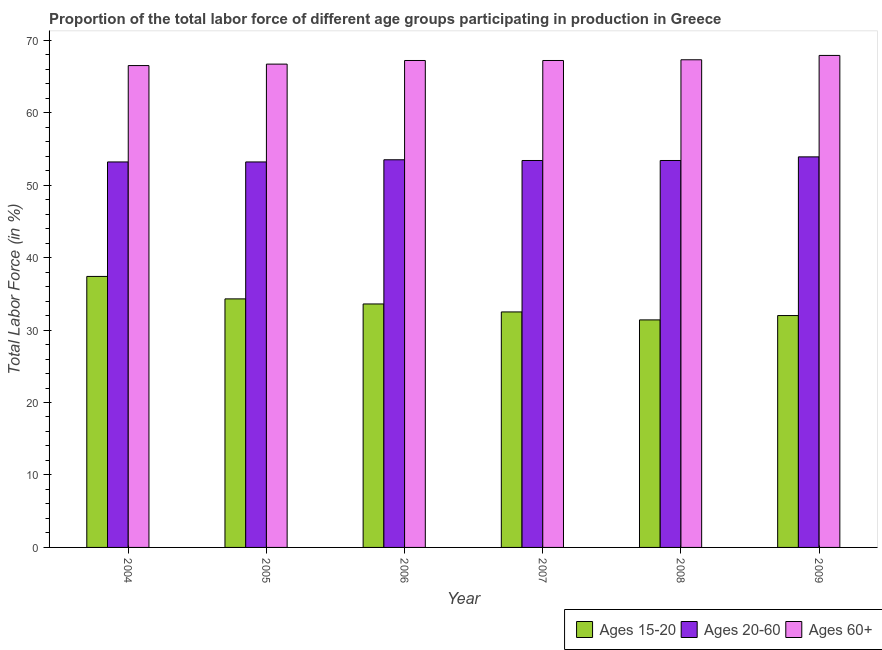How many groups of bars are there?
Offer a very short reply. 6. Are the number of bars on each tick of the X-axis equal?
Your answer should be compact. Yes. How many bars are there on the 2nd tick from the right?
Provide a short and direct response. 3. What is the label of the 1st group of bars from the left?
Your answer should be very brief. 2004. What is the percentage of labor force above age 60 in 2009?
Give a very brief answer. 67.9. Across all years, what is the maximum percentage of labor force within the age group 15-20?
Provide a short and direct response. 37.4. Across all years, what is the minimum percentage of labor force within the age group 15-20?
Make the answer very short. 31.4. In which year was the percentage of labor force within the age group 15-20 minimum?
Give a very brief answer. 2008. What is the total percentage of labor force within the age group 15-20 in the graph?
Provide a short and direct response. 201.2. What is the difference between the percentage of labor force above age 60 in 2007 and that in 2009?
Your answer should be very brief. -0.7. What is the difference between the percentage of labor force above age 60 in 2008 and the percentage of labor force within the age group 20-60 in 2009?
Provide a succinct answer. -0.6. What is the average percentage of labor force above age 60 per year?
Your response must be concise. 67.13. In the year 2007, what is the difference between the percentage of labor force within the age group 15-20 and percentage of labor force above age 60?
Make the answer very short. 0. In how many years, is the percentage of labor force within the age group 20-60 greater than 58 %?
Your answer should be compact. 0. What is the ratio of the percentage of labor force within the age group 15-20 in 2006 to that in 2007?
Offer a very short reply. 1.03. Is the percentage of labor force within the age group 20-60 in 2004 less than that in 2008?
Your answer should be very brief. Yes. Is the difference between the percentage of labor force within the age group 15-20 in 2004 and 2005 greater than the difference between the percentage of labor force within the age group 20-60 in 2004 and 2005?
Give a very brief answer. No. What is the difference between the highest and the second highest percentage of labor force within the age group 20-60?
Keep it short and to the point. 0.4. What is the difference between the highest and the lowest percentage of labor force within the age group 20-60?
Provide a succinct answer. 0.7. What does the 1st bar from the left in 2009 represents?
Give a very brief answer. Ages 15-20. What does the 2nd bar from the right in 2005 represents?
Keep it short and to the point. Ages 20-60. Is it the case that in every year, the sum of the percentage of labor force within the age group 15-20 and percentage of labor force within the age group 20-60 is greater than the percentage of labor force above age 60?
Offer a very short reply. Yes. Are all the bars in the graph horizontal?
Offer a very short reply. No. How many years are there in the graph?
Your answer should be very brief. 6. Does the graph contain grids?
Provide a short and direct response. No. How are the legend labels stacked?
Your answer should be compact. Horizontal. What is the title of the graph?
Offer a very short reply. Proportion of the total labor force of different age groups participating in production in Greece. What is the Total Labor Force (in %) in Ages 15-20 in 2004?
Your response must be concise. 37.4. What is the Total Labor Force (in %) of Ages 20-60 in 2004?
Offer a very short reply. 53.2. What is the Total Labor Force (in %) in Ages 60+ in 2004?
Keep it short and to the point. 66.5. What is the Total Labor Force (in %) of Ages 15-20 in 2005?
Ensure brevity in your answer.  34.3. What is the Total Labor Force (in %) in Ages 20-60 in 2005?
Ensure brevity in your answer.  53.2. What is the Total Labor Force (in %) of Ages 60+ in 2005?
Provide a short and direct response. 66.7. What is the Total Labor Force (in %) in Ages 15-20 in 2006?
Make the answer very short. 33.6. What is the Total Labor Force (in %) of Ages 20-60 in 2006?
Provide a short and direct response. 53.5. What is the Total Labor Force (in %) in Ages 60+ in 2006?
Offer a very short reply. 67.2. What is the Total Labor Force (in %) in Ages 15-20 in 2007?
Keep it short and to the point. 32.5. What is the Total Labor Force (in %) in Ages 20-60 in 2007?
Your answer should be very brief. 53.4. What is the Total Labor Force (in %) of Ages 60+ in 2007?
Ensure brevity in your answer.  67.2. What is the Total Labor Force (in %) of Ages 15-20 in 2008?
Provide a short and direct response. 31.4. What is the Total Labor Force (in %) of Ages 20-60 in 2008?
Keep it short and to the point. 53.4. What is the Total Labor Force (in %) of Ages 60+ in 2008?
Provide a succinct answer. 67.3. What is the Total Labor Force (in %) of Ages 20-60 in 2009?
Give a very brief answer. 53.9. What is the Total Labor Force (in %) of Ages 60+ in 2009?
Offer a terse response. 67.9. Across all years, what is the maximum Total Labor Force (in %) of Ages 15-20?
Provide a short and direct response. 37.4. Across all years, what is the maximum Total Labor Force (in %) of Ages 20-60?
Offer a very short reply. 53.9. Across all years, what is the maximum Total Labor Force (in %) in Ages 60+?
Keep it short and to the point. 67.9. Across all years, what is the minimum Total Labor Force (in %) in Ages 15-20?
Your answer should be very brief. 31.4. Across all years, what is the minimum Total Labor Force (in %) in Ages 20-60?
Offer a very short reply. 53.2. Across all years, what is the minimum Total Labor Force (in %) of Ages 60+?
Provide a succinct answer. 66.5. What is the total Total Labor Force (in %) in Ages 15-20 in the graph?
Your answer should be compact. 201.2. What is the total Total Labor Force (in %) in Ages 20-60 in the graph?
Your answer should be very brief. 320.6. What is the total Total Labor Force (in %) of Ages 60+ in the graph?
Keep it short and to the point. 402.8. What is the difference between the Total Labor Force (in %) in Ages 15-20 in 2004 and that in 2005?
Your answer should be very brief. 3.1. What is the difference between the Total Labor Force (in %) of Ages 60+ in 2004 and that in 2005?
Ensure brevity in your answer.  -0.2. What is the difference between the Total Labor Force (in %) in Ages 15-20 in 2004 and that in 2006?
Keep it short and to the point. 3.8. What is the difference between the Total Labor Force (in %) of Ages 20-60 in 2004 and that in 2006?
Offer a terse response. -0.3. What is the difference between the Total Labor Force (in %) of Ages 60+ in 2004 and that in 2008?
Make the answer very short. -0.8. What is the difference between the Total Labor Force (in %) in Ages 60+ in 2004 and that in 2009?
Keep it short and to the point. -1.4. What is the difference between the Total Labor Force (in %) in Ages 15-20 in 2005 and that in 2006?
Your response must be concise. 0.7. What is the difference between the Total Labor Force (in %) in Ages 20-60 in 2005 and that in 2006?
Provide a short and direct response. -0.3. What is the difference between the Total Labor Force (in %) of Ages 60+ in 2005 and that in 2006?
Your answer should be compact. -0.5. What is the difference between the Total Labor Force (in %) of Ages 20-60 in 2005 and that in 2007?
Your response must be concise. -0.2. What is the difference between the Total Labor Force (in %) of Ages 60+ in 2005 and that in 2007?
Keep it short and to the point. -0.5. What is the difference between the Total Labor Force (in %) in Ages 15-20 in 2005 and that in 2008?
Make the answer very short. 2.9. What is the difference between the Total Labor Force (in %) of Ages 60+ in 2005 and that in 2008?
Ensure brevity in your answer.  -0.6. What is the difference between the Total Labor Force (in %) in Ages 15-20 in 2005 and that in 2009?
Make the answer very short. 2.3. What is the difference between the Total Labor Force (in %) in Ages 20-60 in 2005 and that in 2009?
Give a very brief answer. -0.7. What is the difference between the Total Labor Force (in %) of Ages 15-20 in 2006 and that in 2007?
Offer a terse response. 1.1. What is the difference between the Total Labor Force (in %) in Ages 60+ in 2006 and that in 2007?
Provide a short and direct response. 0. What is the difference between the Total Labor Force (in %) in Ages 15-20 in 2006 and that in 2008?
Your answer should be very brief. 2.2. What is the difference between the Total Labor Force (in %) of Ages 60+ in 2006 and that in 2008?
Offer a very short reply. -0.1. What is the difference between the Total Labor Force (in %) of Ages 20-60 in 2006 and that in 2009?
Keep it short and to the point. -0.4. What is the difference between the Total Labor Force (in %) of Ages 20-60 in 2007 and that in 2008?
Provide a short and direct response. 0. What is the difference between the Total Labor Force (in %) in Ages 15-20 in 2008 and that in 2009?
Offer a very short reply. -0.6. What is the difference between the Total Labor Force (in %) in Ages 20-60 in 2008 and that in 2009?
Provide a short and direct response. -0.5. What is the difference between the Total Labor Force (in %) of Ages 60+ in 2008 and that in 2009?
Provide a succinct answer. -0.6. What is the difference between the Total Labor Force (in %) of Ages 15-20 in 2004 and the Total Labor Force (in %) of Ages 20-60 in 2005?
Offer a terse response. -15.8. What is the difference between the Total Labor Force (in %) in Ages 15-20 in 2004 and the Total Labor Force (in %) in Ages 60+ in 2005?
Your response must be concise. -29.3. What is the difference between the Total Labor Force (in %) of Ages 15-20 in 2004 and the Total Labor Force (in %) of Ages 20-60 in 2006?
Provide a short and direct response. -16.1. What is the difference between the Total Labor Force (in %) in Ages 15-20 in 2004 and the Total Labor Force (in %) in Ages 60+ in 2006?
Give a very brief answer. -29.8. What is the difference between the Total Labor Force (in %) in Ages 20-60 in 2004 and the Total Labor Force (in %) in Ages 60+ in 2006?
Give a very brief answer. -14. What is the difference between the Total Labor Force (in %) in Ages 15-20 in 2004 and the Total Labor Force (in %) in Ages 60+ in 2007?
Your answer should be compact. -29.8. What is the difference between the Total Labor Force (in %) of Ages 20-60 in 2004 and the Total Labor Force (in %) of Ages 60+ in 2007?
Provide a succinct answer. -14. What is the difference between the Total Labor Force (in %) of Ages 15-20 in 2004 and the Total Labor Force (in %) of Ages 60+ in 2008?
Give a very brief answer. -29.9. What is the difference between the Total Labor Force (in %) in Ages 20-60 in 2004 and the Total Labor Force (in %) in Ages 60+ in 2008?
Your answer should be compact. -14.1. What is the difference between the Total Labor Force (in %) in Ages 15-20 in 2004 and the Total Labor Force (in %) in Ages 20-60 in 2009?
Your response must be concise. -16.5. What is the difference between the Total Labor Force (in %) of Ages 15-20 in 2004 and the Total Labor Force (in %) of Ages 60+ in 2009?
Offer a very short reply. -30.5. What is the difference between the Total Labor Force (in %) in Ages 20-60 in 2004 and the Total Labor Force (in %) in Ages 60+ in 2009?
Offer a terse response. -14.7. What is the difference between the Total Labor Force (in %) of Ages 15-20 in 2005 and the Total Labor Force (in %) of Ages 20-60 in 2006?
Your answer should be compact. -19.2. What is the difference between the Total Labor Force (in %) of Ages 15-20 in 2005 and the Total Labor Force (in %) of Ages 60+ in 2006?
Your answer should be very brief. -32.9. What is the difference between the Total Labor Force (in %) in Ages 15-20 in 2005 and the Total Labor Force (in %) in Ages 20-60 in 2007?
Provide a succinct answer. -19.1. What is the difference between the Total Labor Force (in %) in Ages 15-20 in 2005 and the Total Labor Force (in %) in Ages 60+ in 2007?
Your answer should be very brief. -32.9. What is the difference between the Total Labor Force (in %) in Ages 15-20 in 2005 and the Total Labor Force (in %) in Ages 20-60 in 2008?
Offer a very short reply. -19.1. What is the difference between the Total Labor Force (in %) in Ages 15-20 in 2005 and the Total Labor Force (in %) in Ages 60+ in 2008?
Keep it short and to the point. -33. What is the difference between the Total Labor Force (in %) of Ages 20-60 in 2005 and the Total Labor Force (in %) of Ages 60+ in 2008?
Your response must be concise. -14.1. What is the difference between the Total Labor Force (in %) of Ages 15-20 in 2005 and the Total Labor Force (in %) of Ages 20-60 in 2009?
Ensure brevity in your answer.  -19.6. What is the difference between the Total Labor Force (in %) of Ages 15-20 in 2005 and the Total Labor Force (in %) of Ages 60+ in 2009?
Your answer should be very brief. -33.6. What is the difference between the Total Labor Force (in %) of Ages 20-60 in 2005 and the Total Labor Force (in %) of Ages 60+ in 2009?
Ensure brevity in your answer.  -14.7. What is the difference between the Total Labor Force (in %) of Ages 15-20 in 2006 and the Total Labor Force (in %) of Ages 20-60 in 2007?
Make the answer very short. -19.8. What is the difference between the Total Labor Force (in %) in Ages 15-20 in 2006 and the Total Labor Force (in %) in Ages 60+ in 2007?
Make the answer very short. -33.6. What is the difference between the Total Labor Force (in %) of Ages 20-60 in 2006 and the Total Labor Force (in %) of Ages 60+ in 2007?
Give a very brief answer. -13.7. What is the difference between the Total Labor Force (in %) in Ages 15-20 in 2006 and the Total Labor Force (in %) in Ages 20-60 in 2008?
Provide a succinct answer. -19.8. What is the difference between the Total Labor Force (in %) in Ages 15-20 in 2006 and the Total Labor Force (in %) in Ages 60+ in 2008?
Provide a succinct answer. -33.7. What is the difference between the Total Labor Force (in %) in Ages 15-20 in 2006 and the Total Labor Force (in %) in Ages 20-60 in 2009?
Your response must be concise. -20.3. What is the difference between the Total Labor Force (in %) in Ages 15-20 in 2006 and the Total Labor Force (in %) in Ages 60+ in 2009?
Offer a terse response. -34.3. What is the difference between the Total Labor Force (in %) of Ages 20-60 in 2006 and the Total Labor Force (in %) of Ages 60+ in 2009?
Give a very brief answer. -14.4. What is the difference between the Total Labor Force (in %) of Ages 15-20 in 2007 and the Total Labor Force (in %) of Ages 20-60 in 2008?
Provide a short and direct response. -20.9. What is the difference between the Total Labor Force (in %) of Ages 15-20 in 2007 and the Total Labor Force (in %) of Ages 60+ in 2008?
Your answer should be very brief. -34.8. What is the difference between the Total Labor Force (in %) in Ages 15-20 in 2007 and the Total Labor Force (in %) in Ages 20-60 in 2009?
Provide a succinct answer. -21.4. What is the difference between the Total Labor Force (in %) of Ages 15-20 in 2007 and the Total Labor Force (in %) of Ages 60+ in 2009?
Give a very brief answer. -35.4. What is the difference between the Total Labor Force (in %) in Ages 20-60 in 2007 and the Total Labor Force (in %) in Ages 60+ in 2009?
Give a very brief answer. -14.5. What is the difference between the Total Labor Force (in %) in Ages 15-20 in 2008 and the Total Labor Force (in %) in Ages 20-60 in 2009?
Your answer should be compact. -22.5. What is the difference between the Total Labor Force (in %) of Ages 15-20 in 2008 and the Total Labor Force (in %) of Ages 60+ in 2009?
Offer a terse response. -36.5. What is the average Total Labor Force (in %) of Ages 15-20 per year?
Ensure brevity in your answer.  33.53. What is the average Total Labor Force (in %) of Ages 20-60 per year?
Ensure brevity in your answer.  53.43. What is the average Total Labor Force (in %) of Ages 60+ per year?
Provide a short and direct response. 67.13. In the year 2004, what is the difference between the Total Labor Force (in %) of Ages 15-20 and Total Labor Force (in %) of Ages 20-60?
Provide a succinct answer. -15.8. In the year 2004, what is the difference between the Total Labor Force (in %) of Ages 15-20 and Total Labor Force (in %) of Ages 60+?
Offer a very short reply. -29.1. In the year 2005, what is the difference between the Total Labor Force (in %) in Ages 15-20 and Total Labor Force (in %) in Ages 20-60?
Your response must be concise. -18.9. In the year 2005, what is the difference between the Total Labor Force (in %) in Ages 15-20 and Total Labor Force (in %) in Ages 60+?
Give a very brief answer. -32.4. In the year 2006, what is the difference between the Total Labor Force (in %) of Ages 15-20 and Total Labor Force (in %) of Ages 20-60?
Provide a short and direct response. -19.9. In the year 2006, what is the difference between the Total Labor Force (in %) in Ages 15-20 and Total Labor Force (in %) in Ages 60+?
Make the answer very short. -33.6. In the year 2006, what is the difference between the Total Labor Force (in %) in Ages 20-60 and Total Labor Force (in %) in Ages 60+?
Make the answer very short. -13.7. In the year 2007, what is the difference between the Total Labor Force (in %) in Ages 15-20 and Total Labor Force (in %) in Ages 20-60?
Keep it short and to the point. -20.9. In the year 2007, what is the difference between the Total Labor Force (in %) in Ages 15-20 and Total Labor Force (in %) in Ages 60+?
Make the answer very short. -34.7. In the year 2008, what is the difference between the Total Labor Force (in %) of Ages 15-20 and Total Labor Force (in %) of Ages 20-60?
Your answer should be compact. -22. In the year 2008, what is the difference between the Total Labor Force (in %) in Ages 15-20 and Total Labor Force (in %) in Ages 60+?
Provide a succinct answer. -35.9. In the year 2009, what is the difference between the Total Labor Force (in %) of Ages 15-20 and Total Labor Force (in %) of Ages 20-60?
Offer a terse response. -21.9. In the year 2009, what is the difference between the Total Labor Force (in %) in Ages 15-20 and Total Labor Force (in %) in Ages 60+?
Provide a short and direct response. -35.9. What is the ratio of the Total Labor Force (in %) in Ages 15-20 in 2004 to that in 2005?
Provide a succinct answer. 1.09. What is the ratio of the Total Labor Force (in %) of Ages 20-60 in 2004 to that in 2005?
Keep it short and to the point. 1. What is the ratio of the Total Labor Force (in %) of Ages 60+ in 2004 to that in 2005?
Make the answer very short. 1. What is the ratio of the Total Labor Force (in %) of Ages 15-20 in 2004 to that in 2006?
Provide a short and direct response. 1.11. What is the ratio of the Total Labor Force (in %) of Ages 15-20 in 2004 to that in 2007?
Ensure brevity in your answer.  1.15. What is the ratio of the Total Labor Force (in %) in Ages 20-60 in 2004 to that in 2007?
Provide a short and direct response. 1. What is the ratio of the Total Labor Force (in %) in Ages 15-20 in 2004 to that in 2008?
Offer a very short reply. 1.19. What is the ratio of the Total Labor Force (in %) in Ages 20-60 in 2004 to that in 2008?
Your answer should be very brief. 1. What is the ratio of the Total Labor Force (in %) of Ages 60+ in 2004 to that in 2008?
Give a very brief answer. 0.99. What is the ratio of the Total Labor Force (in %) in Ages 15-20 in 2004 to that in 2009?
Ensure brevity in your answer.  1.17. What is the ratio of the Total Labor Force (in %) in Ages 60+ in 2004 to that in 2009?
Your answer should be very brief. 0.98. What is the ratio of the Total Labor Force (in %) of Ages 15-20 in 2005 to that in 2006?
Give a very brief answer. 1.02. What is the ratio of the Total Labor Force (in %) in Ages 15-20 in 2005 to that in 2007?
Your answer should be very brief. 1.06. What is the ratio of the Total Labor Force (in %) in Ages 20-60 in 2005 to that in 2007?
Provide a succinct answer. 1. What is the ratio of the Total Labor Force (in %) of Ages 60+ in 2005 to that in 2007?
Make the answer very short. 0.99. What is the ratio of the Total Labor Force (in %) in Ages 15-20 in 2005 to that in 2008?
Give a very brief answer. 1.09. What is the ratio of the Total Labor Force (in %) of Ages 15-20 in 2005 to that in 2009?
Give a very brief answer. 1.07. What is the ratio of the Total Labor Force (in %) of Ages 60+ in 2005 to that in 2009?
Provide a short and direct response. 0.98. What is the ratio of the Total Labor Force (in %) of Ages 15-20 in 2006 to that in 2007?
Ensure brevity in your answer.  1.03. What is the ratio of the Total Labor Force (in %) of Ages 20-60 in 2006 to that in 2007?
Your answer should be compact. 1. What is the ratio of the Total Labor Force (in %) in Ages 60+ in 2006 to that in 2007?
Your answer should be very brief. 1. What is the ratio of the Total Labor Force (in %) in Ages 15-20 in 2006 to that in 2008?
Your response must be concise. 1.07. What is the ratio of the Total Labor Force (in %) in Ages 20-60 in 2006 to that in 2008?
Your response must be concise. 1. What is the ratio of the Total Labor Force (in %) in Ages 15-20 in 2006 to that in 2009?
Provide a succinct answer. 1.05. What is the ratio of the Total Labor Force (in %) of Ages 20-60 in 2006 to that in 2009?
Your answer should be very brief. 0.99. What is the ratio of the Total Labor Force (in %) of Ages 15-20 in 2007 to that in 2008?
Your answer should be compact. 1.03. What is the ratio of the Total Labor Force (in %) of Ages 15-20 in 2007 to that in 2009?
Your response must be concise. 1.02. What is the ratio of the Total Labor Force (in %) of Ages 20-60 in 2007 to that in 2009?
Your answer should be compact. 0.99. What is the ratio of the Total Labor Force (in %) in Ages 15-20 in 2008 to that in 2009?
Offer a terse response. 0.98. What is the difference between the highest and the second highest Total Labor Force (in %) in Ages 15-20?
Your response must be concise. 3.1. What is the difference between the highest and the second highest Total Labor Force (in %) in Ages 60+?
Make the answer very short. 0.6. What is the difference between the highest and the lowest Total Labor Force (in %) of Ages 15-20?
Your response must be concise. 6. What is the difference between the highest and the lowest Total Labor Force (in %) in Ages 20-60?
Provide a short and direct response. 0.7. 